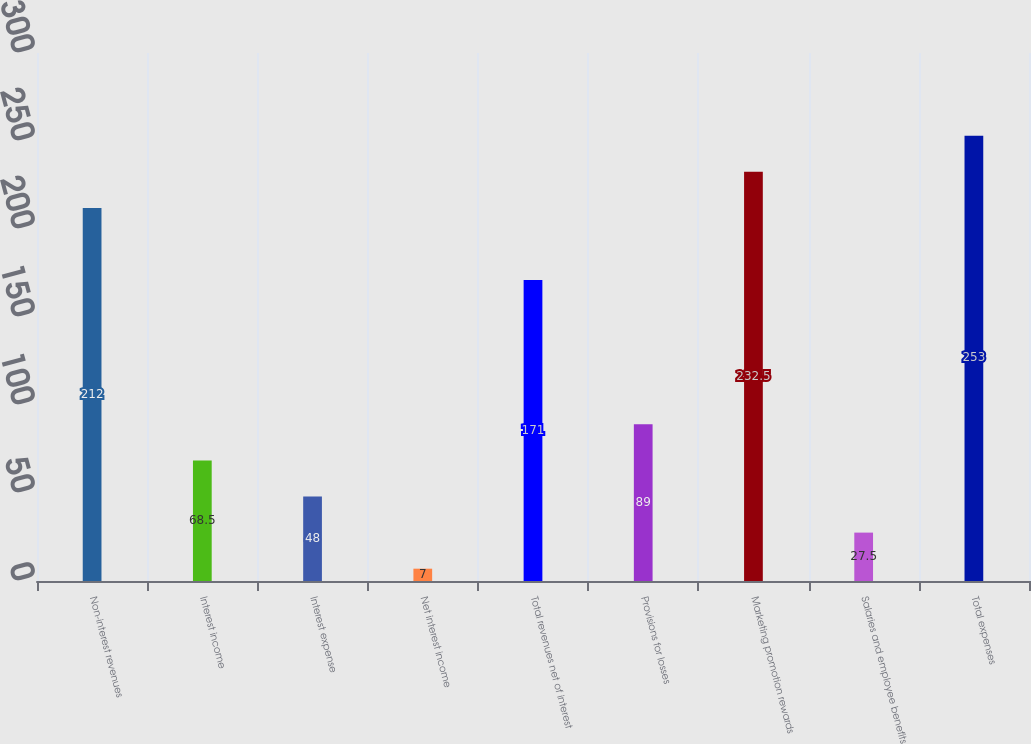Convert chart to OTSL. <chart><loc_0><loc_0><loc_500><loc_500><bar_chart><fcel>Non-interest revenues<fcel>Interest income<fcel>Interest expense<fcel>Net interest income<fcel>Total revenues net of interest<fcel>Provisions for losses<fcel>Marketing promotion rewards<fcel>Salaries and employee benefits<fcel>Total expenses<nl><fcel>212<fcel>68.5<fcel>48<fcel>7<fcel>171<fcel>89<fcel>232.5<fcel>27.5<fcel>253<nl></chart> 